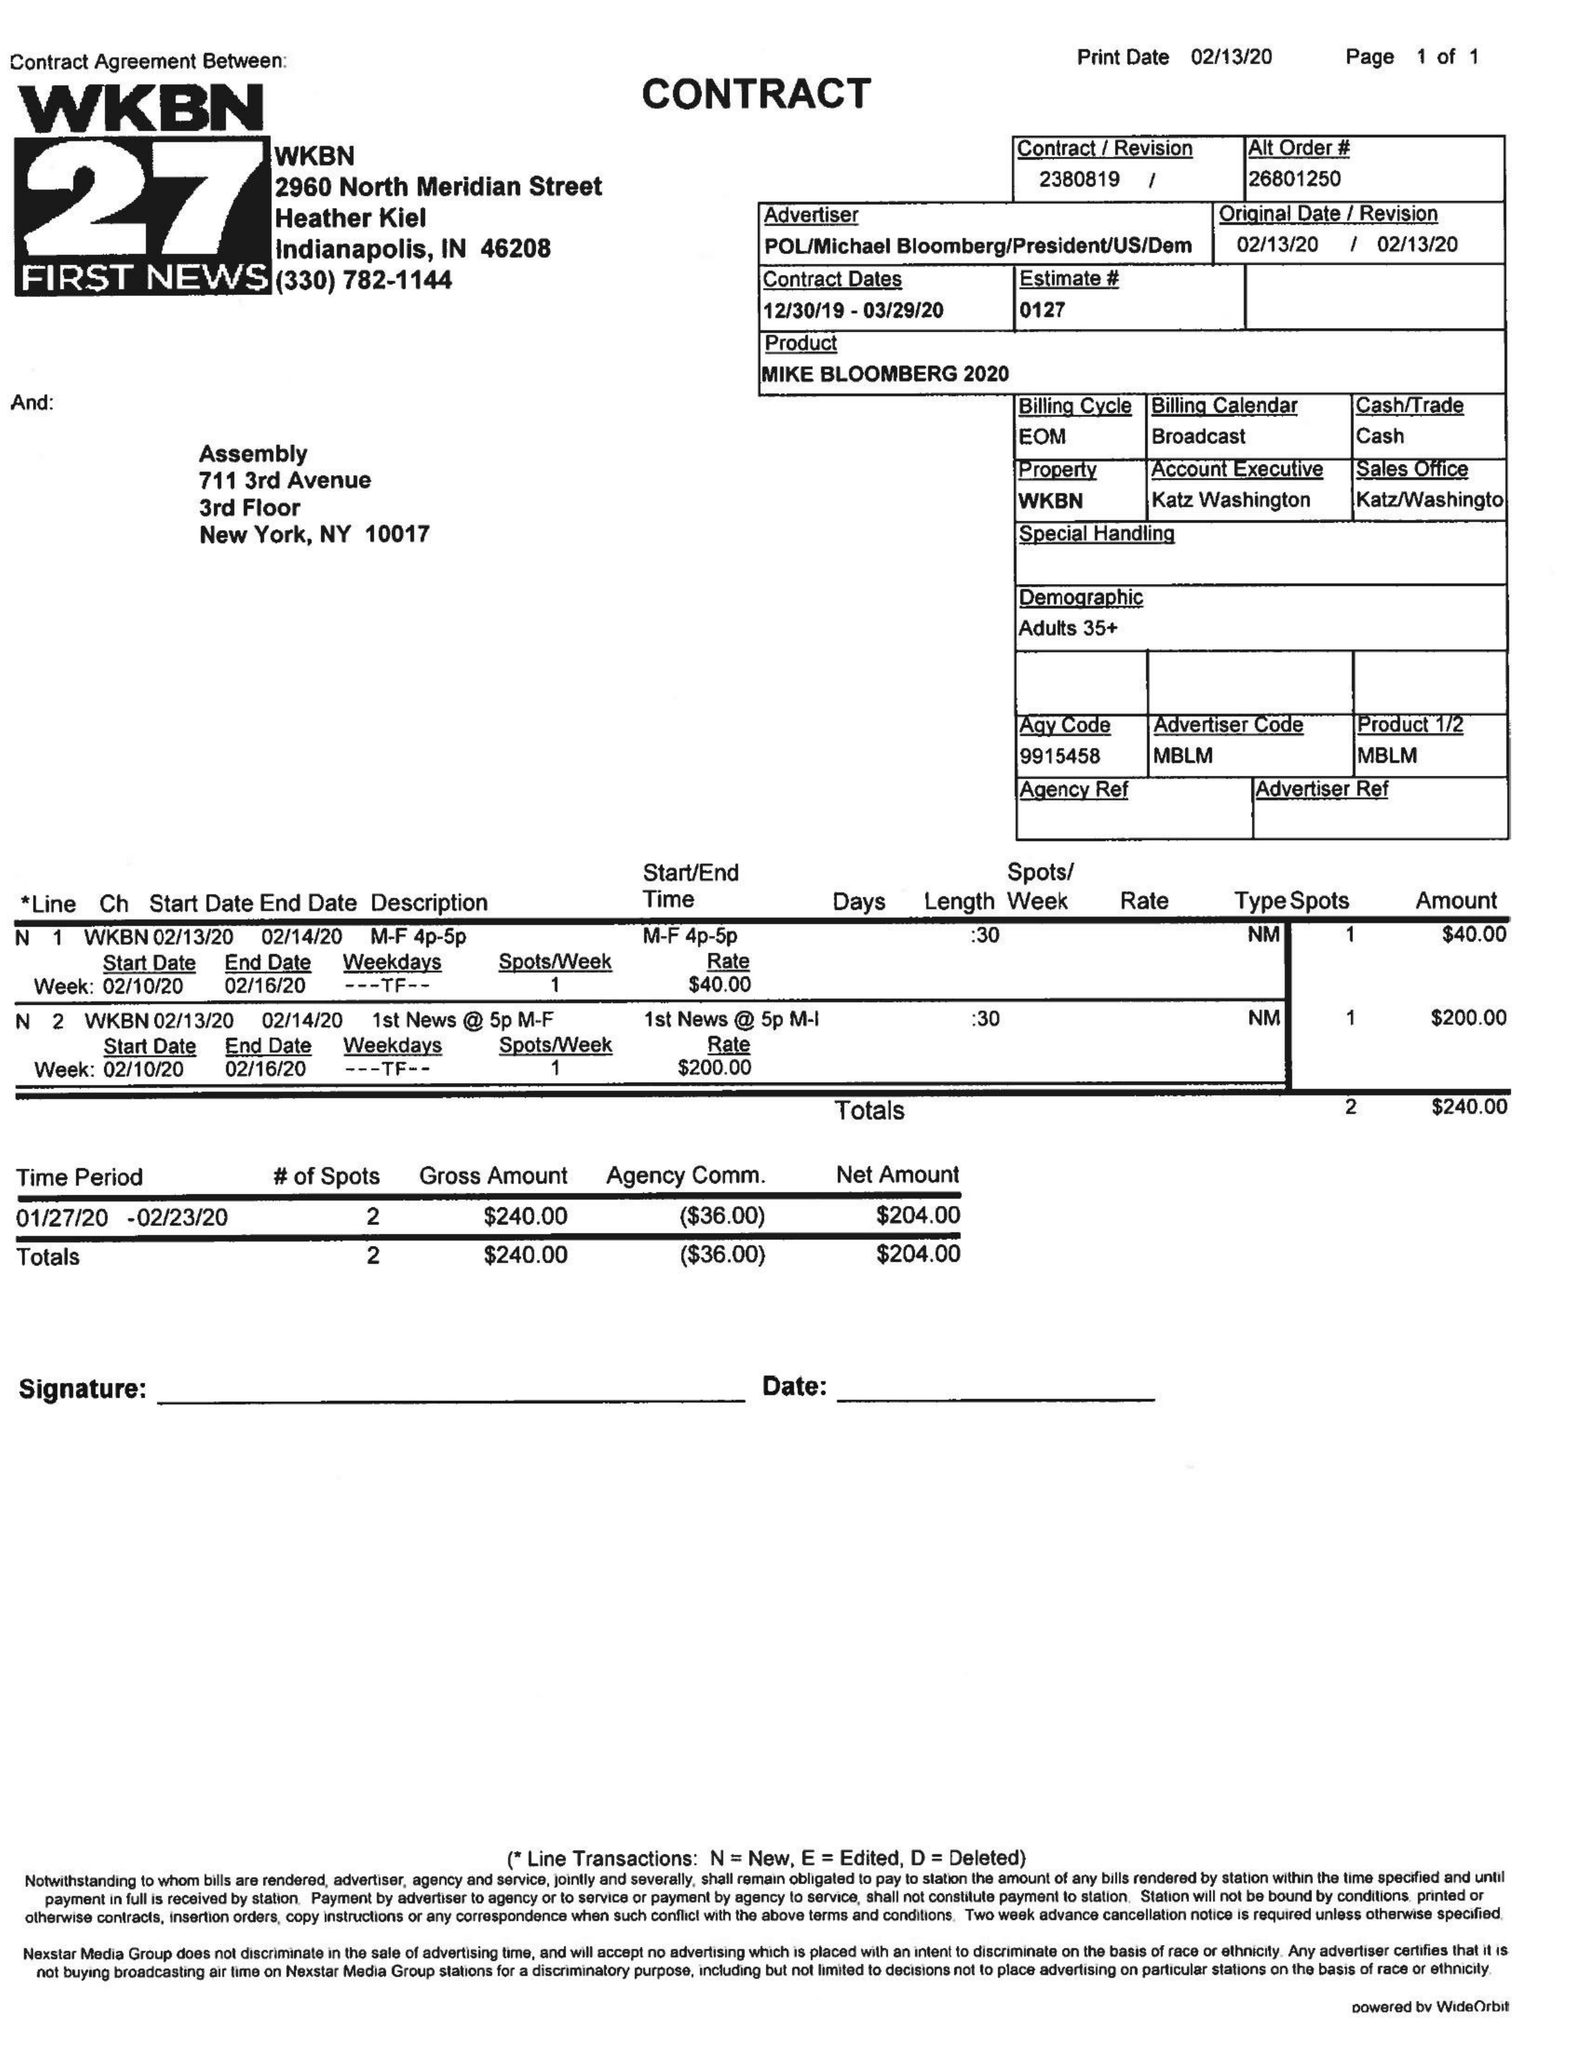What is the value for the flight_from?
Answer the question using a single word or phrase. 12/30/19 